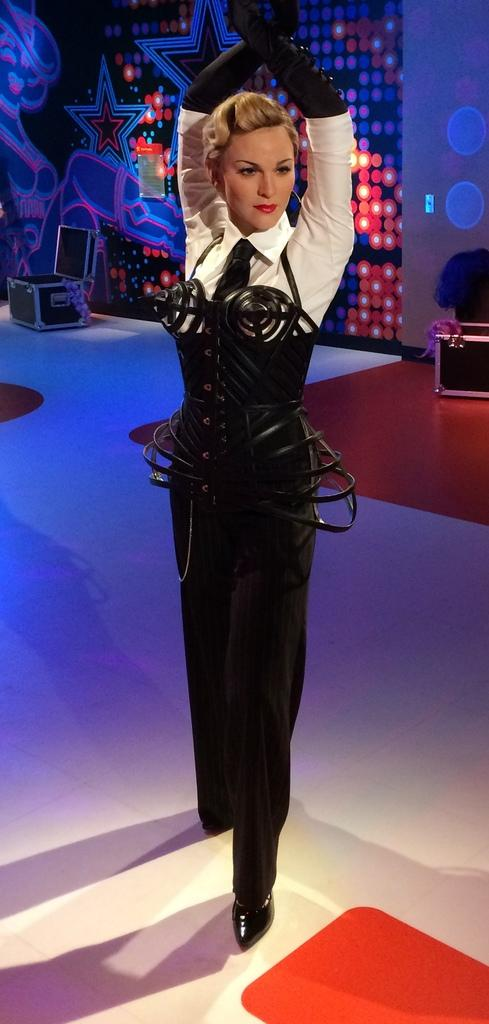What is the main subject in the image? There is a lady standing in the image. Where is the lady standing? The lady is standing on the floor. What can be seen behind the lady? There are objects placed behind the lady. What is visible in the background of the image? There is a wall in the background of the image. How much payment is the lady receiving for her performance in the image? There is no indication of a performance or payment in the image; it simply shows a lady standing. 